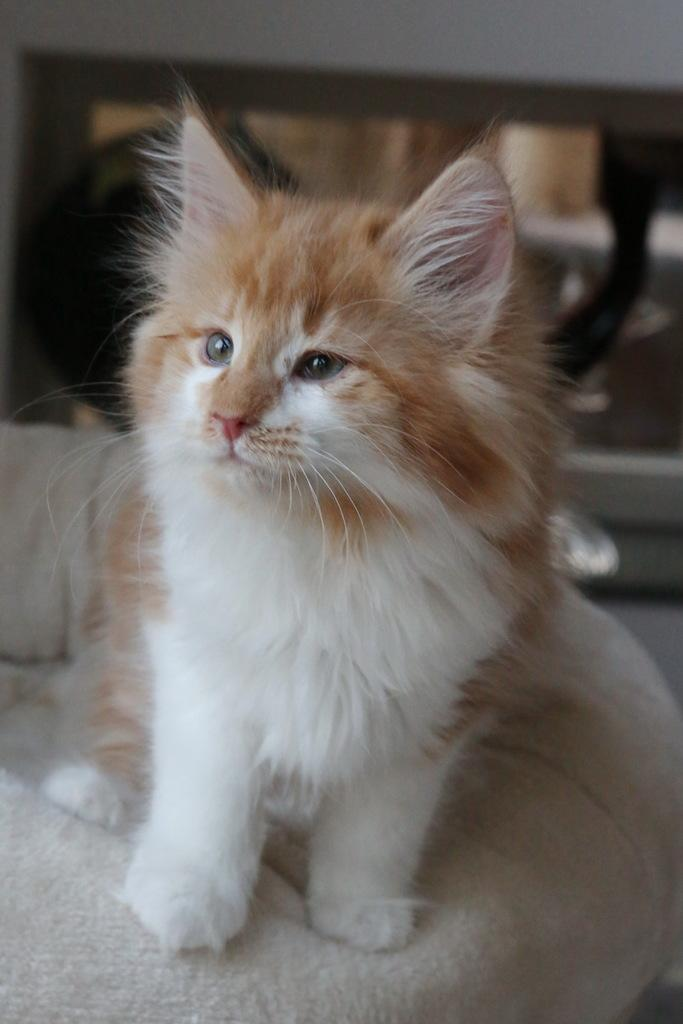What animal can be seen in the image? There is a cat in the image. Where is the cat located? The cat is sitting on a couch. What is behind the cat? There is a wall behind the cat. Can you describe anything on the wall? There is a picture frame on the wall. What type of business is being conducted by the squirrel in the image? There is no squirrel present in the image, and therefore no business is being conducted. What does the nose of the cat look like in the image? The image does not provide a close-up view of the cat's nose, so it cannot be described in detail. 